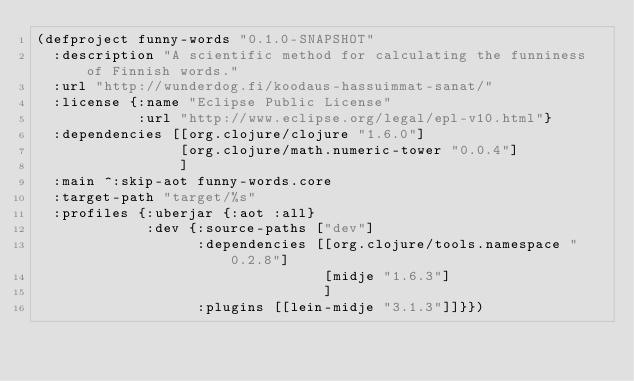Convert code to text. <code><loc_0><loc_0><loc_500><loc_500><_Clojure_>(defproject funny-words "0.1.0-SNAPSHOT"
  :description "A scientific method for calculating the funniness of Finnish words."
  :url "http://wunderdog.fi/koodaus-hassuimmat-sanat/"
  :license {:name "Eclipse Public License"
            :url "http://www.eclipse.org/legal/epl-v10.html"}
  :dependencies [[org.clojure/clojure "1.6.0"]
                 [org.clojure/math.numeric-tower "0.0.4"]
                 ]
  :main ^:skip-aot funny-words.core
  :target-path "target/%s"
  :profiles {:uberjar {:aot :all}
             :dev {:source-paths ["dev"]
                   :dependencies [[org.clojure/tools.namespace "0.2.8"]
                                  [midje "1.6.3"]
                                  ]
                   :plugins [[lein-midje "3.1.3"]]}})
</code> 